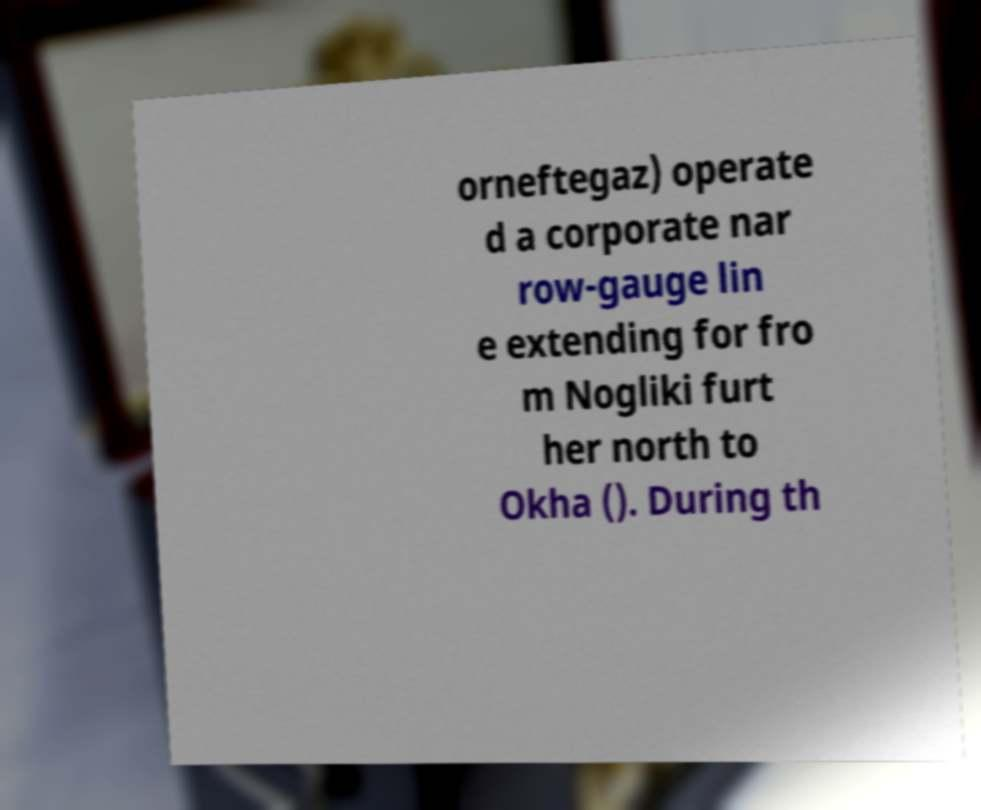I need the written content from this picture converted into text. Can you do that? orneftegaz) operate d a corporate nar row-gauge lin e extending for fro m Nogliki furt her north to Okha (). During th 